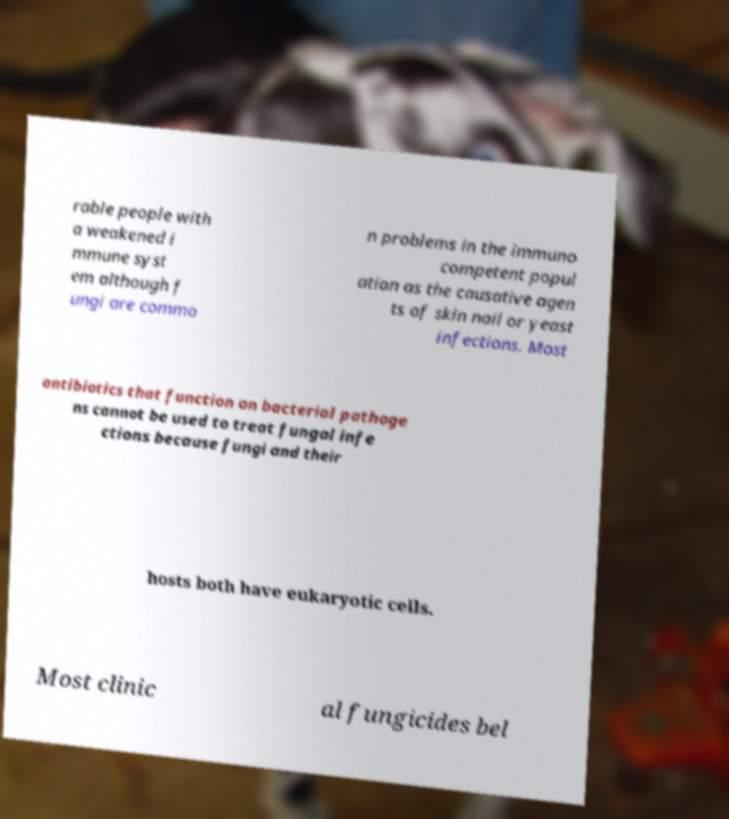Could you extract and type out the text from this image? rable people with a weakened i mmune syst em although f ungi are commo n problems in the immuno competent popul ation as the causative agen ts of skin nail or yeast infections. Most antibiotics that function on bacterial pathoge ns cannot be used to treat fungal infe ctions because fungi and their hosts both have eukaryotic cells. Most clinic al fungicides bel 